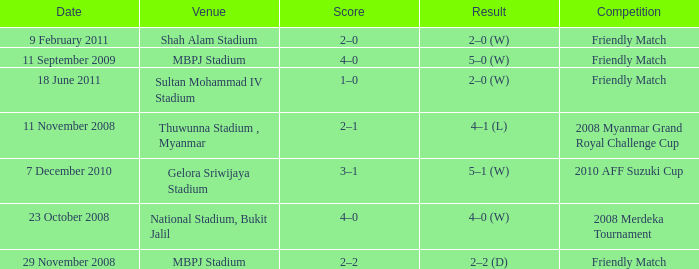What is the Venue of the Competition with a Result of 2–2 (d)? MBPJ Stadium. 